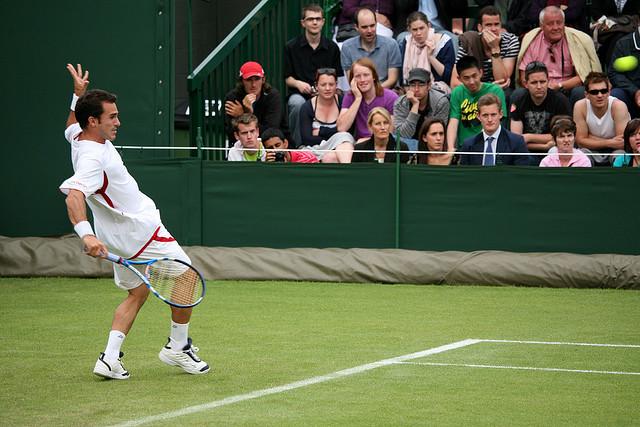Does the player look excited?
Answer briefly. Yes. Are all the players on the same team?
Short answer required. No. Which sport is this?
Give a very brief answer. Tennis. Is this tennis sport?
Keep it brief. Yes. Is it chilly out?
Short answer required. No. 